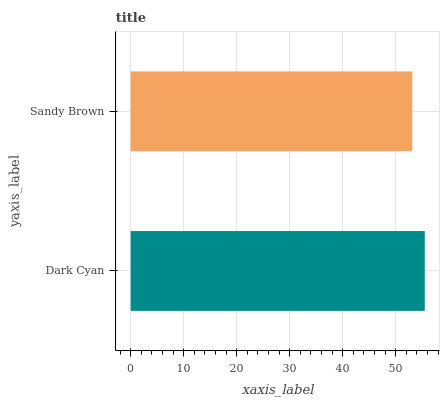Is Sandy Brown the minimum?
Answer yes or no. Yes. Is Dark Cyan the maximum?
Answer yes or no. Yes. Is Sandy Brown the maximum?
Answer yes or no. No. Is Dark Cyan greater than Sandy Brown?
Answer yes or no. Yes. Is Sandy Brown less than Dark Cyan?
Answer yes or no. Yes. Is Sandy Brown greater than Dark Cyan?
Answer yes or no. No. Is Dark Cyan less than Sandy Brown?
Answer yes or no. No. Is Dark Cyan the high median?
Answer yes or no. Yes. Is Sandy Brown the low median?
Answer yes or no. Yes. Is Sandy Brown the high median?
Answer yes or no. No. Is Dark Cyan the low median?
Answer yes or no. No. 